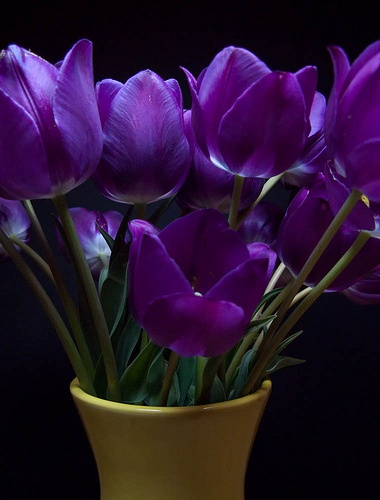Describe the objects in this image and their specific colors. I can see potted plant in black, navy, and purple tones and vase in black and olive tones in this image. 